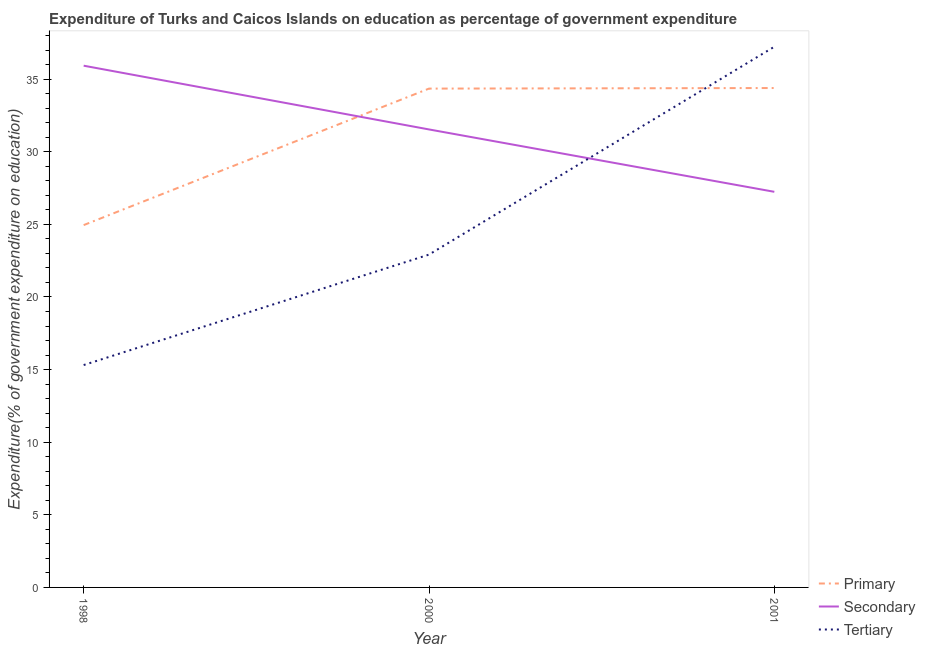How many different coloured lines are there?
Offer a very short reply. 3. Does the line corresponding to expenditure on primary education intersect with the line corresponding to expenditure on secondary education?
Provide a short and direct response. Yes. What is the expenditure on secondary education in 1998?
Your response must be concise. 35.93. Across all years, what is the maximum expenditure on tertiary education?
Offer a terse response. 37.23. Across all years, what is the minimum expenditure on primary education?
Your answer should be compact. 24.95. In which year was the expenditure on secondary education minimum?
Provide a short and direct response. 2001. What is the total expenditure on secondary education in the graph?
Your response must be concise. 94.71. What is the difference between the expenditure on secondary education in 2000 and that in 2001?
Your answer should be compact. 4.3. What is the difference between the expenditure on tertiary education in 2001 and the expenditure on secondary education in 2000?
Provide a short and direct response. 5.69. What is the average expenditure on primary education per year?
Make the answer very short. 31.23. In the year 2000, what is the difference between the expenditure on secondary education and expenditure on tertiary education?
Give a very brief answer. 8.62. What is the ratio of the expenditure on secondary education in 1998 to that in 2001?
Your response must be concise. 1.32. Is the expenditure on primary education in 2000 less than that in 2001?
Provide a short and direct response. Yes. Is the difference between the expenditure on primary education in 1998 and 2000 greater than the difference between the expenditure on secondary education in 1998 and 2000?
Your answer should be compact. No. What is the difference between the highest and the second highest expenditure on secondary education?
Make the answer very short. 4.39. What is the difference between the highest and the lowest expenditure on secondary education?
Keep it short and to the point. 8.69. In how many years, is the expenditure on primary education greater than the average expenditure on primary education taken over all years?
Your answer should be very brief. 2. Is the sum of the expenditure on secondary education in 1998 and 2000 greater than the maximum expenditure on tertiary education across all years?
Your response must be concise. Yes. Is it the case that in every year, the sum of the expenditure on primary education and expenditure on secondary education is greater than the expenditure on tertiary education?
Offer a terse response. Yes. Does the expenditure on secondary education monotonically increase over the years?
Ensure brevity in your answer.  No. Is the expenditure on tertiary education strictly less than the expenditure on secondary education over the years?
Provide a short and direct response. No. How many lines are there?
Make the answer very short. 3. What is the difference between two consecutive major ticks on the Y-axis?
Ensure brevity in your answer.  5. Does the graph contain any zero values?
Your answer should be very brief. No. Does the graph contain grids?
Offer a very short reply. No. Where does the legend appear in the graph?
Provide a succinct answer. Bottom right. How are the legend labels stacked?
Your answer should be compact. Vertical. What is the title of the graph?
Your answer should be compact. Expenditure of Turks and Caicos Islands on education as percentage of government expenditure. Does "Liquid fuel" appear as one of the legend labels in the graph?
Ensure brevity in your answer.  No. What is the label or title of the X-axis?
Keep it short and to the point. Year. What is the label or title of the Y-axis?
Offer a very short reply. Expenditure(% of government expenditure on education). What is the Expenditure(% of government expenditure on education) of Primary in 1998?
Your answer should be compact. 24.95. What is the Expenditure(% of government expenditure on education) in Secondary in 1998?
Make the answer very short. 35.93. What is the Expenditure(% of government expenditure on education) of Tertiary in 1998?
Your answer should be compact. 15.31. What is the Expenditure(% of government expenditure on education) in Primary in 2000?
Keep it short and to the point. 34.35. What is the Expenditure(% of government expenditure on education) of Secondary in 2000?
Offer a very short reply. 31.54. What is the Expenditure(% of government expenditure on education) of Tertiary in 2000?
Make the answer very short. 22.92. What is the Expenditure(% of government expenditure on education) in Primary in 2001?
Make the answer very short. 34.39. What is the Expenditure(% of government expenditure on education) of Secondary in 2001?
Your response must be concise. 27.24. What is the Expenditure(% of government expenditure on education) of Tertiary in 2001?
Offer a very short reply. 37.23. Across all years, what is the maximum Expenditure(% of government expenditure on education) of Primary?
Make the answer very short. 34.39. Across all years, what is the maximum Expenditure(% of government expenditure on education) of Secondary?
Provide a short and direct response. 35.93. Across all years, what is the maximum Expenditure(% of government expenditure on education) of Tertiary?
Your answer should be compact. 37.23. Across all years, what is the minimum Expenditure(% of government expenditure on education) in Primary?
Offer a very short reply. 24.95. Across all years, what is the minimum Expenditure(% of government expenditure on education) in Secondary?
Your answer should be very brief. 27.24. Across all years, what is the minimum Expenditure(% of government expenditure on education) in Tertiary?
Offer a terse response. 15.31. What is the total Expenditure(% of government expenditure on education) of Primary in the graph?
Offer a very short reply. 93.69. What is the total Expenditure(% of government expenditure on education) of Secondary in the graph?
Your answer should be very brief. 94.71. What is the total Expenditure(% of government expenditure on education) in Tertiary in the graph?
Your response must be concise. 75.47. What is the difference between the Expenditure(% of government expenditure on education) of Primary in 1998 and that in 2000?
Your answer should be very brief. -9.4. What is the difference between the Expenditure(% of government expenditure on education) in Secondary in 1998 and that in 2000?
Offer a terse response. 4.39. What is the difference between the Expenditure(% of government expenditure on education) of Tertiary in 1998 and that in 2000?
Your answer should be very brief. -7.61. What is the difference between the Expenditure(% of government expenditure on education) of Primary in 1998 and that in 2001?
Keep it short and to the point. -9.44. What is the difference between the Expenditure(% of government expenditure on education) in Secondary in 1998 and that in 2001?
Provide a succinct answer. 8.69. What is the difference between the Expenditure(% of government expenditure on education) in Tertiary in 1998 and that in 2001?
Your answer should be very brief. -21.92. What is the difference between the Expenditure(% of government expenditure on education) in Primary in 2000 and that in 2001?
Your response must be concise. -0.04. What is the difference between the Expenditure(% of government expenditure on education) in Secondary in 2000 and that in 2001?
Your answer should be compact. 4.3. What is the difference between the Expenditure(% of government expenditure on education) in Tertiary in 2000 and that in 2001?
Your response must be concise. -14.31. What is the difference between the Expenditure(% of government expenditure on education) in Primary in 1998 and the Expenditure(% of government expenditure on education) in Secondary in 2000?
Offer a terse response. -6.59. What is the difference between the Expenditure(% of government expenditure on education) in Primary in 1998 and the Expenditure(% of government expenditure on education) in Tertiary in 2000?
Give a very brief answer. 2.03. What is the difference between the Expenditure(% of government expenditure on education) in Secondary in 1998 and the Expenditure(% of government expenditure on education) in Tertiary in 2000?
Ensure brevity in your answer.  13.01. What is the difference between the Expenditure(% of government expenditure on education) of Primary in 1998 and the Expenditure(% of government expenditure on education) of Secondary in 2001?
Make the answer very short. -2.29. What is the difference between the Expenditure(% of government expenditure on education) in Primary in 1998 and the Expenditure(% of government expenditure on education) in Tertiary in 2001?
Keep it short and to the point. -12.28. What is the difference between the Expenditure(% of government expenditure on education) of Secondary in 1998 and the Expenditure(% of government expenditure on education) of Tertiary in 2001?
Ensure brevity in your answer.  -1.3. What is the difference between the Expenditure(% of government expenditure on education) in Primary in 2000 and the Expenditure(% of government expenditure on education) in Secondary in 2001?
Your response must be concise. 7.11. What is the difference between the Expenditure(% of government expenditure on education) in Primary in 2000 and the Expenditure(% of government expenditure on education) in Tertiary in 2001?
Your answer should be compact. -2.88. What is the difference between the Expenditure(% of government expenditure on education) of Secondary in 2000 and the Expenditure(% of government expenditure on education) of Tertiary in 2001?
Give a very brief answer. -5.69. What is the average Expenditure(% of government expenditure on education) in Primary per year?
Make the answer very short. 31.23. What is the average Expenditure(% of government expenditure on education) of Secondary per year?
Ensure brevity in your answer.  31.57. What is the average Expenditure(% of government expenditure on education) in Tertiary per year?
Your answer should be very brief. 25.16. In the year 1998, what is the difference between the Expenditure(% of government expenditure on education) of Primary and Expenditure(% of government expenditure on education) of Secondary?
Your response must be concise. -10.98. In the year 1998, what is the difference between the Expenditure(% of government expenditure on education) of Primary and Expenditure(% of government expenditure on education) of Tertiary?
Your answer should be compact. 9.64. In the year 1998, what is the difference between the Expenditure(% of government expenditure on education) in Secondary and Expenditure(% of government expenditure on education) in Tertiary?
Offer a terse response. 20.61. In the year 2000, what is the difference between the Expenditure(% of government expenditure on education) of Primary and Expenditure(% of government expenditure on education) of Secondary?
Ensure brevity in your answer.  2.81. In the year 2000, what is the difference between the Expenditure(% of government expenditure on education) of Primary and Expenditure(% of government expenditure on education) of Tertiary?
Your answer should be compact. 11.43. In the year 2000, what is the difference between the Expenditure(% of government expenditure on education) of Secondary and Expenditure(% of government expenditure on education) of Tertiary?
Ensure brevity in your answer.  8.62. In the year 2001, what is the difference between the Expenditure(% of government expenditure on education) of Primary and Expenditure(% of government expenditure on education) of Secondary?
Offer a terse response. 7.15. In the year 2001, what is the difference between the Expenditure(% of government expenditure on education) in Primary and Expenditure(% of government expenditure on education) in Tertiary?
Your response must be concise. -2.84. In the year 2001, what is the difference between the Expenditure(% of government expenditure on education) of Secondary and Expenditure(% of government expenditure on education) of Tertiary?
Make the answer very short. -9.99. What is the ratio of the Expenditure(% of government expenditure on education) in Primary in 1998 to that in 2000?
Provide a short and direct response. 0.73. What is the ratio of the Expenditure(% of government expenditure on education) of Secondary in 1998 to that in 2000?
Make the answer very short. 1.14. What is the ratio of the Expenditure(% of government expenditure on education) of Tertiary in 1998 to that in 2000?
Keep it short and to the point. 0.67. What is the ratio of the Expenditure(% of government expenditure on education) of Primary in 1998 to that in 2001?
Your answer should be compact. 0.73. What is the ratio of the Expenditure(% of government expenditure on education) in Secondary in 1998 to that in 2001?
Provide a short and direct response. 1.32. What is the ratio of the Expenditure(% of government expenditure on education) of Tertiary in 1998 to that in 2001?
Offer a terse response. 0.41. What is the ratio of the Expenditure(% of government expenditure on education) of Primary in 2000 to that in 2001?
Provide a short and direct response. 1. What is the ratio of the Expenditure(% of government expenditure on education) in Secondary in 2000 to that in 2001?
Ensure brevity in your answer.  1.16. What is the ratio of the Expenditure(% of government expenditure on education) of Tertiary in 2000 to that in 2001?
Your response must be concise. 0.62. What is the difference between the highest and the second highest Expenditure(% of government expenditure on education) in Primary?
Ensure brevity in your answer.  0.04. What is the difference between the highest and the second highest Expenditure(% of government expenditure on education) of Secondary?
Offer a very short reply. 4.39. What is the difference between the highest and the second highest Expenditure(% of government expenditure on education) in Tertiary?
Ensure brevity in your answer.  14.31. What is the difference between the highest and the lowest Expenditure(% of government expenditure on education) of Primary?
Provide a short and direct response. 9.44. What is the difference between the highest and the lowest Expenditure(% of government expenditure on education) of Secondary?
Your answer should be very brief. 8.69. What is the difference between the highest and the lowest Expenditure(% of government expenditure on education) in Tertiary?
Ensure brevity in your answer.  21.92. 